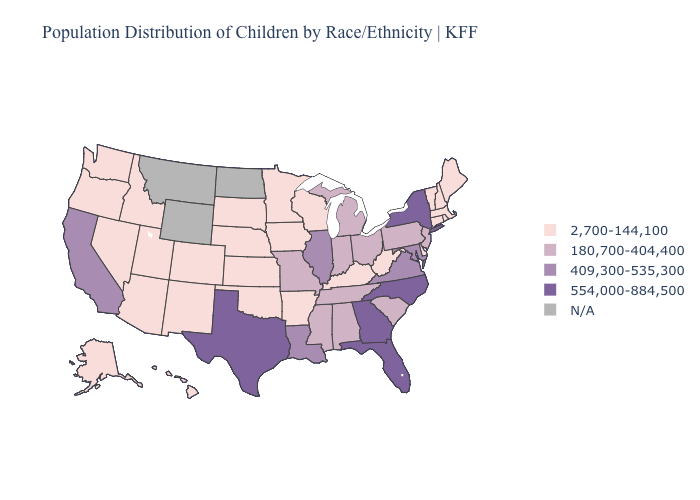What is the highest value in states that border Wyoming?
Be succinct. 2,700-144,100. Which states have the lowest value in the USA?
Short answer required. Alaska, Arizona, Arkansas, Colorado, Connecticut, Delaware, Hawaii, Idaho, Iowa, Kansas, Kentucky, Maine, Massachusetts, Minnesota, Nebraska, Nevada, New Hampshire, New Mexico, Oklahoma, Oregon, Rhode Island, South Dakota, Utah, Vermont, Washington, West Virginia, Wisconsin. What is the value of Iowa?
Be succinct. 2,700-144,100. Among the states that border Kentucky , does West Virginia have the highest value?
Concise answer only. No. Which states have the lowest value in the USA?
Be succinct. Alaska, Arizona, Arkansas, Colorado, Connecticut, Delaware, Hawaii, Idaho, Iowa, Kansas, Kentucky, Maine, Massachusetts, Minnesota, Nebraska, Nevada, New Hampshire, New Mexico, Oklahoma, Oregon, Rhode Island, South Dakota, Utah, Vermont, Washington, West Virginia, Wisconsin. Name the states that have a value in the range 409,300-535,300?
Concise answer only. California, Illinois, Louisiana, Maryland, Virginia. Which states hav the highest value in the South?
Give a very brief answer. Florida, Georgia, North Carolina, Texas. Is the legend a continuous bar?
Be succinct. No. Is the legend a continuous bar?
Concise answer only. No. Does Utah have the lowest value in the USA?
Be succinct. Yes. What is the value of Arkansas?
Answer briefly. 2,700-144,100. What is the value of Montana?
Quick response, please. N/A. What is the value of Minnesota?
Quick response, please. 2,700-144,100. What is the highest value in the South ?
Keep it brief. 554,000-884,500. 